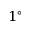Convert formula to latex. <formula><loc_0><loc_0><loc_500><loc_500>1 ^ { \circ }</formula> 